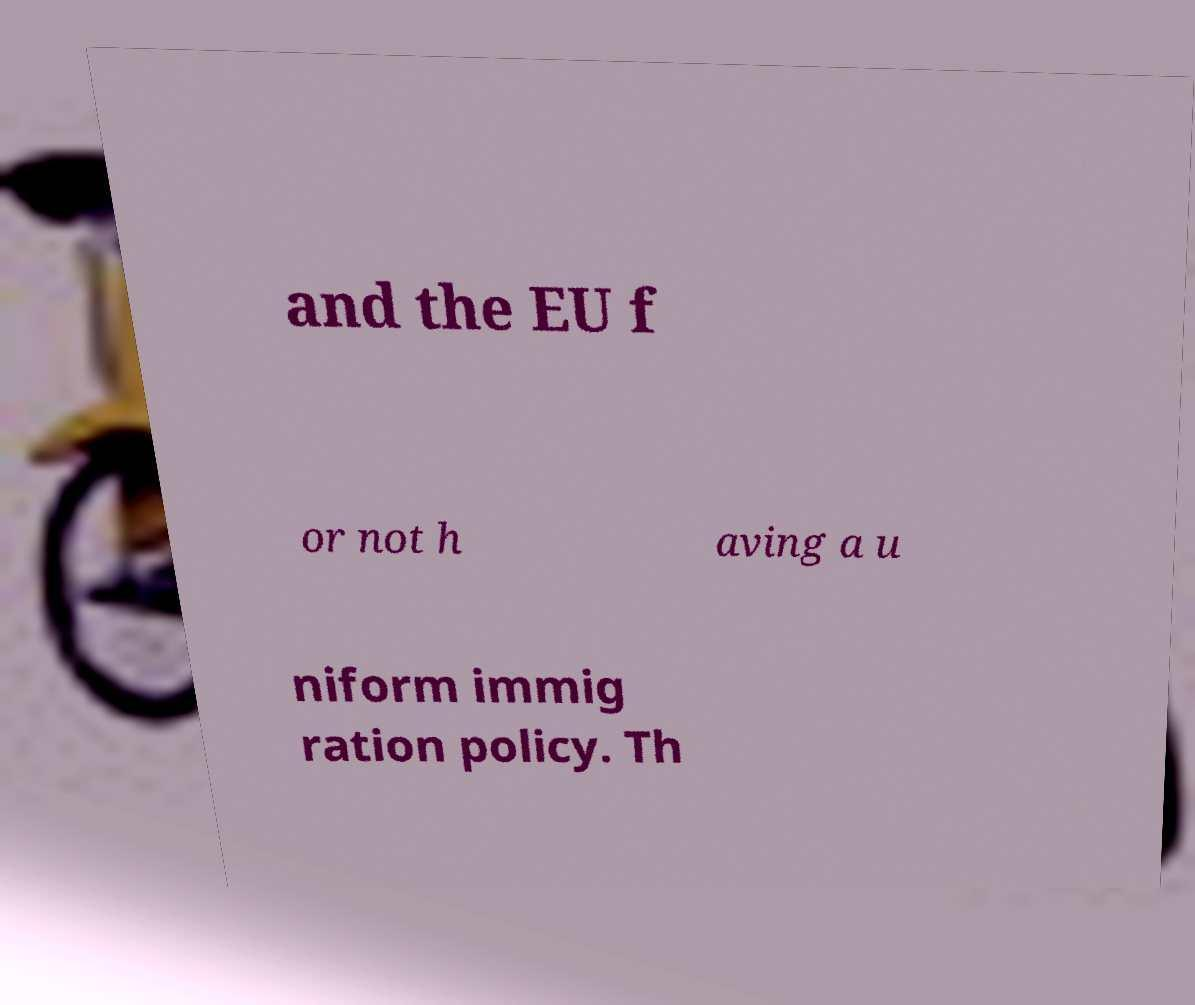Can you accurately transcribe the text from the provided image for me? and the EU f or not h aving a u niform immig ration policy. Th 